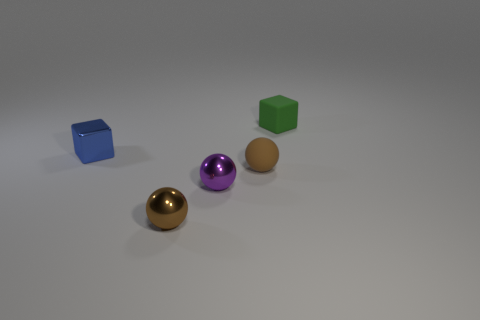Subtract all metallic spheres. How many spheres are left? 1 Add 3 green things. How many objects exist? 8 Subtract all metallic objects. Subtract all tiny yellow objects. How many objects are left? 2 Add 1 tiny shiny cubes. How many tiny shiny cubes are left? 2 Add 3 brown matte objects. How many brown matte objects exist? 4 Subtract 0 cyan cylinders. How many objects are left? 5 Subtract all cubes. How many objects are left? 3 